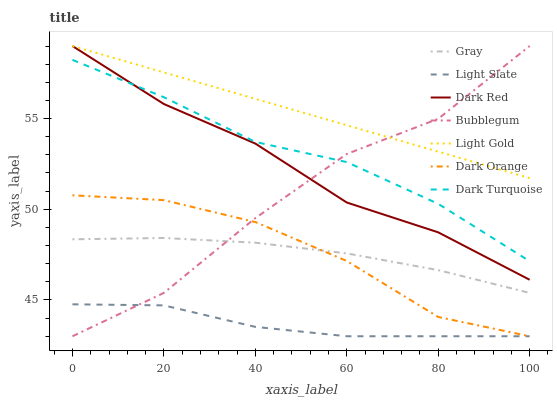Does Light Slate have the minimum area under the curve?
Answer yes or no. Yes. Does Light Gold have the maximum area under the curve?
Answer yes or no. Yes. Does Dark Orange have the minimum area under the curve?
Answer yes or no. No. Does Dark Orange have the maximum area under the curve?
Answer yes or no. No. Is Light Gold the smoothest?
Answer yes or no. Yes. Is Bubblegum the roughest?
Answer yes or no. Yes. Is Dark Orange the smoothest?
Answer yes or no. No. Is Dark Orange the roughest?
Answer yes or no. No. Does Dark Orange have the lowest value?
Answer yes or no. Yes. Does Dark Red have the lowest value?
Answer yes or no. No. Does Light Gold have the highest value?
Answer yes or no. Yes. Does Dark Orange have the highest value?
Answer yes or no. No. Is Light Slate less than Dark Red?
Answer yes or no. Yes. Is Dark Turquoise greater than Dark Orange?
Answer yes or no. Yes. Does Light Slate intersect Bubblegum?
Answer yes or no. Yes. Is Light Slate less than Bubblegum?
Answer yes or no. No. Is Light Slate greater than Bubblegum?
Answer yes or no. No. Does Light Slate intersect Dark Red?
Answer yes or no. No. 